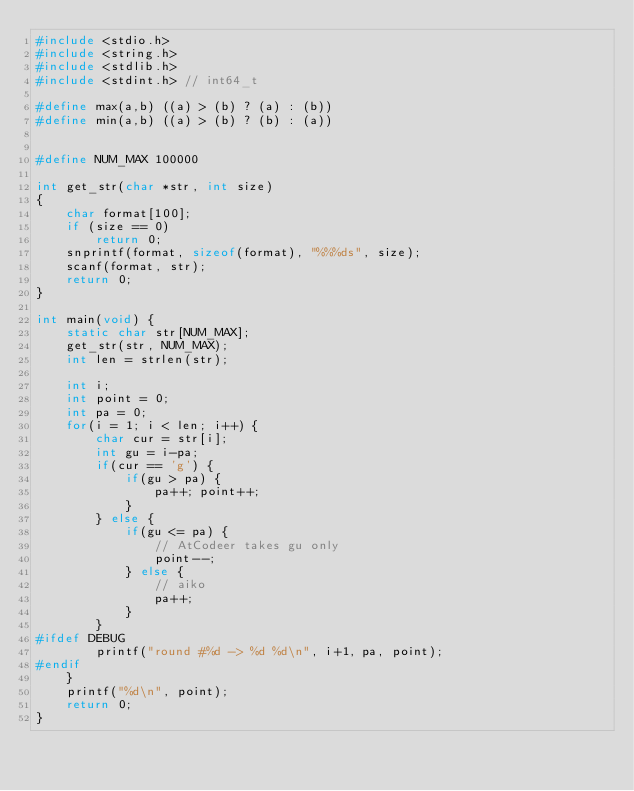<code> <loc_0><loc_0><loc_500><loc_500><_C_>#include <stdio.h>
#include <string.h>
#include <stdlib.h>
#include <stdint.h> // int64_t

#define max(a,b) ((a) > (b) ? (a) : (b))
#define min(a,b) ((a) > (b) ? (b) : (a))


#define NUM_MAX 100000

int get_str(char *str, int size)
{
    char format[100];
    if (size == 0)
        return 0;
    snprintf(format, sizeof(format), "%%%ds", size);
    scanf(format, str);
    return 0;
}

int main(void) {
    static char str[NUM_MAX];
    get_str(str, NUM_MAX);
    int len = strlen(str);

    int i;
    int point = 0;
    int pa = 0;
    for(i = 1; i < len; i++) {
        char cur = str[i];
        int gu = i-pa;
        if(cur == 'g') {
            if(gu > pa) {
                pa++; point++;
            }
        } else {
            if(gu <= pa) {
                // AtCodeer takes gu only
                point--;
            } else {
                // aiko
                pa++;
            }
        }
#ifdef DEBUG
        printf("round #%d -> %d %d\n", i+1, pa, point);
#endif
    }
    printf("%d\n", point);
    return 0;
}</code> 